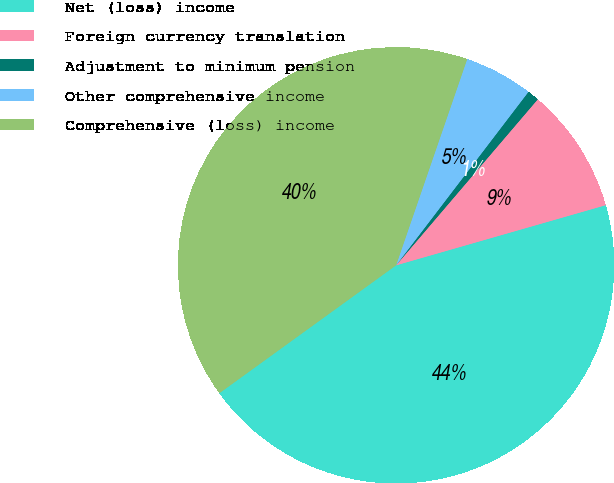Convert chart to OTSL. <chart><loc_0><loc_0><loc_500><loc_500><pie_chart><fcel>Net (loss) income<fcel>Foreign currency translation<fcel>Adjustment to minimum pension<fcel>Other comprehensive income<fcel>Comprehensive (loss) income<nl><fcel>44.48%<fcel>9.31%<fcel>0.87%<fcel>5.09%<fcel>40.26%<nl></chart> 